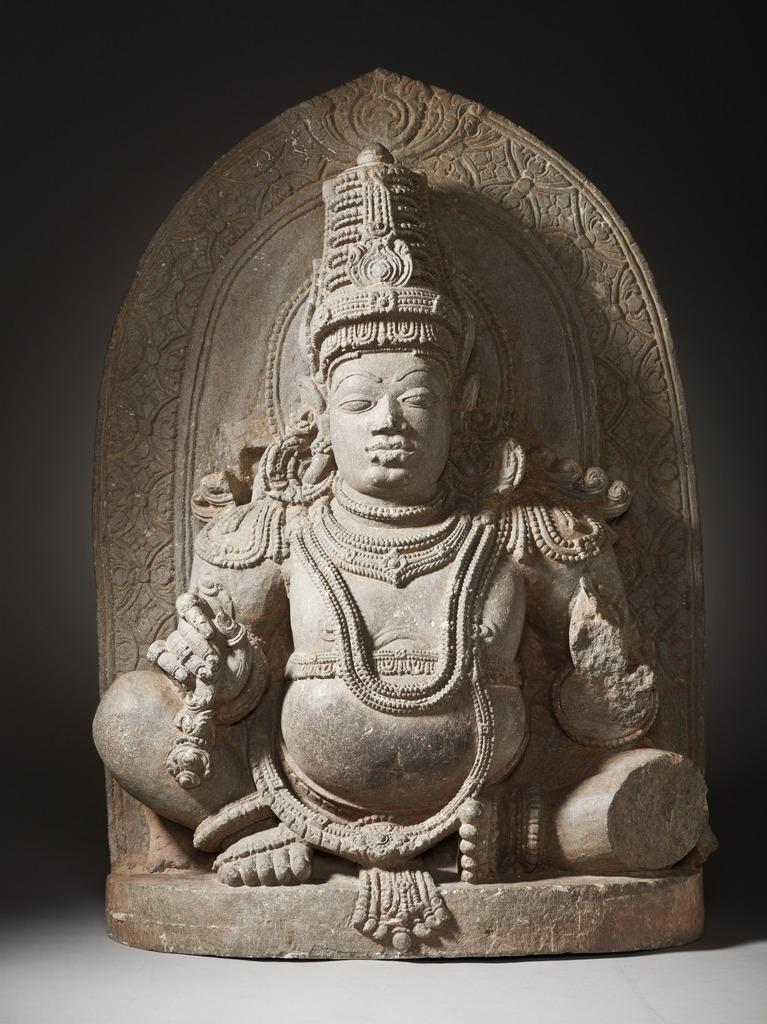Please provide a concise description of this image. In this image I can see a statute which is in grey and brown color. Background is in black color. 